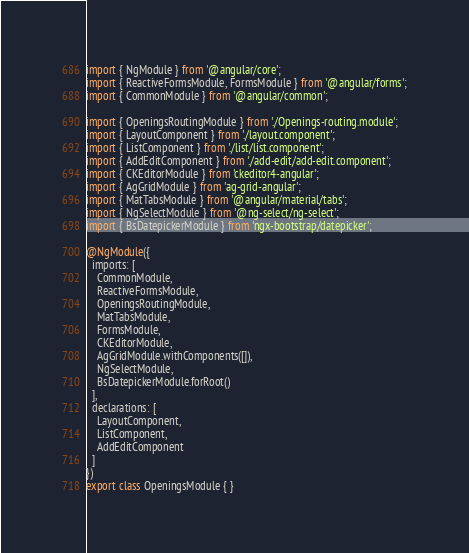Convert code to text. <code><loc_0><loc_0><loc_500><loc_500><_TypeScript_>import { NgModule } from '@angular/core';
import { ReactiveFormsModule, FormsModule } from '@angular/forms';
import { CommonModule } from '@angular/common';

import { OpeningsRoutingModule } from './Openings-routing.module';
import { LayoutComponent } from './layout.component';
import { ListComponent } from './list/list.component';
import { AddEditComponent } from './add-edit/add-edit.component';
import { CKEditorModule } from 'ckeditor4-angular';
import { AgGridModule } from 'ag-grid-angular';
import { MatTabsModule } from '@angular/material/tabs';
import { NgSelectModule } from '@ng-select/ng-select';
import { BsDatepickerModule } from 'ngx-bootstrap/datepicker';

@NgModule({
  imports: [
    CommonModule,
    ReactiveFormsModule,
    OpeningsRoutingModule,
    MatTabsModule,
    FormsModule,
    CKEditorModule,
    AgGridModule.withComponents([]),
    NgSelectModule,
    BsDatepickerModule.forRoot()
  ],
  declarations: [
    LayoutComponent,
    ListComponent,
    AddEditComponent
  ]
})
export class OpeningsModule { }
</code> 